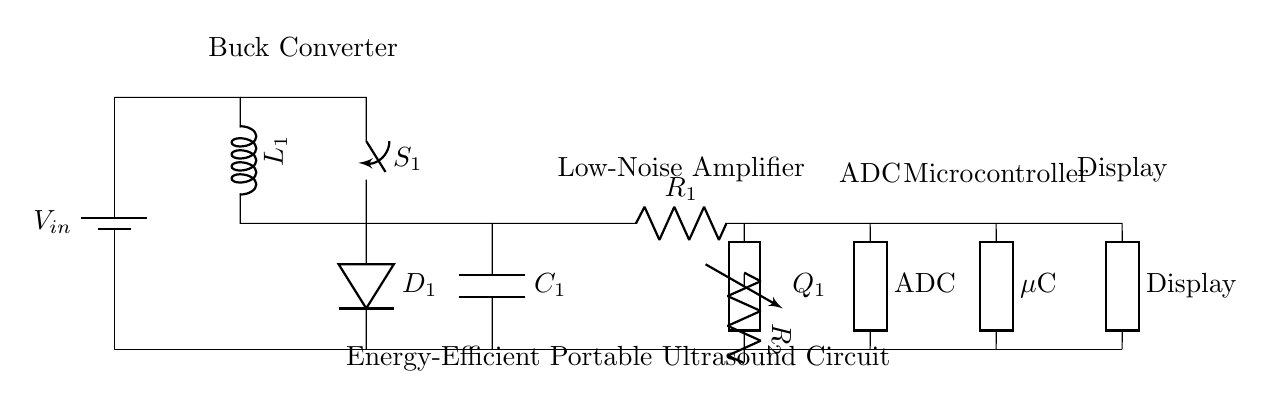What is the primary function of the buck converter in this circuit? The buck converter steps down the input voltage to a lower output voltage suitable for the subsequent components in the circuit.
Answer: Step-down What type of transistor is used in this circuit? The circuit uses an NPN transistor indicated by the symbol 'Q1' with a label for current amplification.
Answer: NPN How many resistors are present in the circuit? There are two resistors (R1 and R2) shown in the circuit diagram.
Answer: Two What component converts the analog signals to digital in this circuit? The component that performs this function is the Analog-to-Digital Converter labeled as 'ADC'.
Answer: ADC What type of load is attached to the microcontroller? The microcontroller connects to a display component for showing the processed information, indicating that it drives a visual output load.
Answer: Display What is the role of the low-noise amplifier in the circuit? The low-noise amplifier (LNA) amplifies the ultrasound signals received to ensure that the subsequent processing is done on a clear and strong signal, minimizing noise.
Answer: Amplification What is the purpose of the capacitor in this circuit? The capacitor is used to smooth out the voltage fluctuations at the output of the buck converter, ensuring stable power supply to the amplifier and other components.
Answer: Power smoothing 